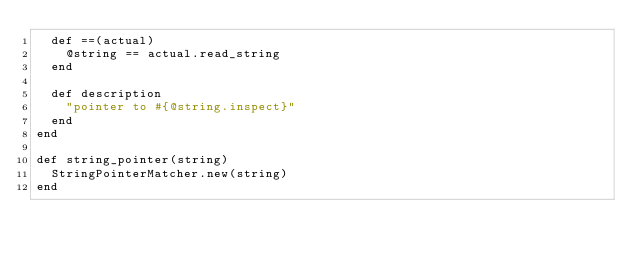Convert code to text. <code><loc_0><loc_0><loc_500><loc_500><_Ruby_>  def ==(actual)
    @string == actual.read_string
  end

  def description
    "pointer to #{@string.inspect}"
  end
end

def string_pointer(string)
  StringPointerMatcher.new(string)
end
</code> 